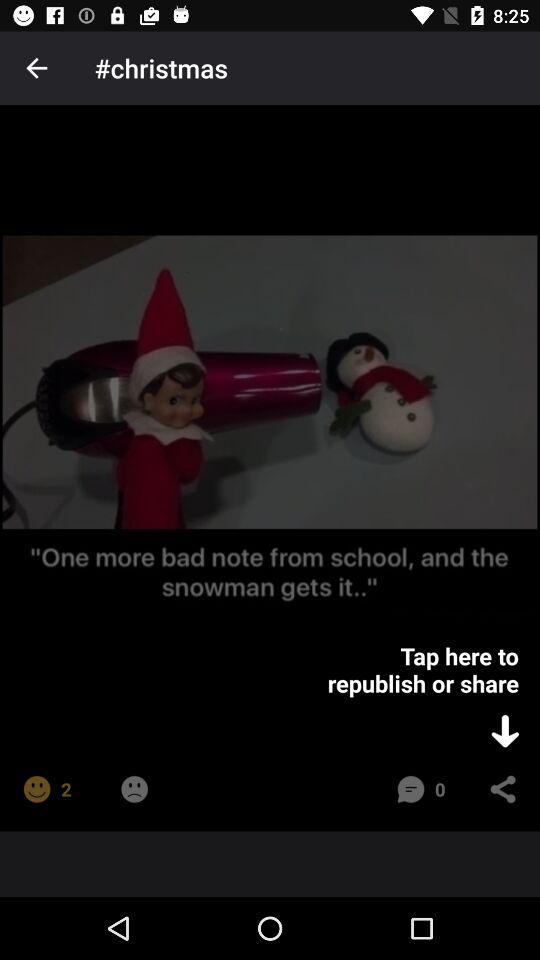What's the number of smileys? The number of smileys is 2. 